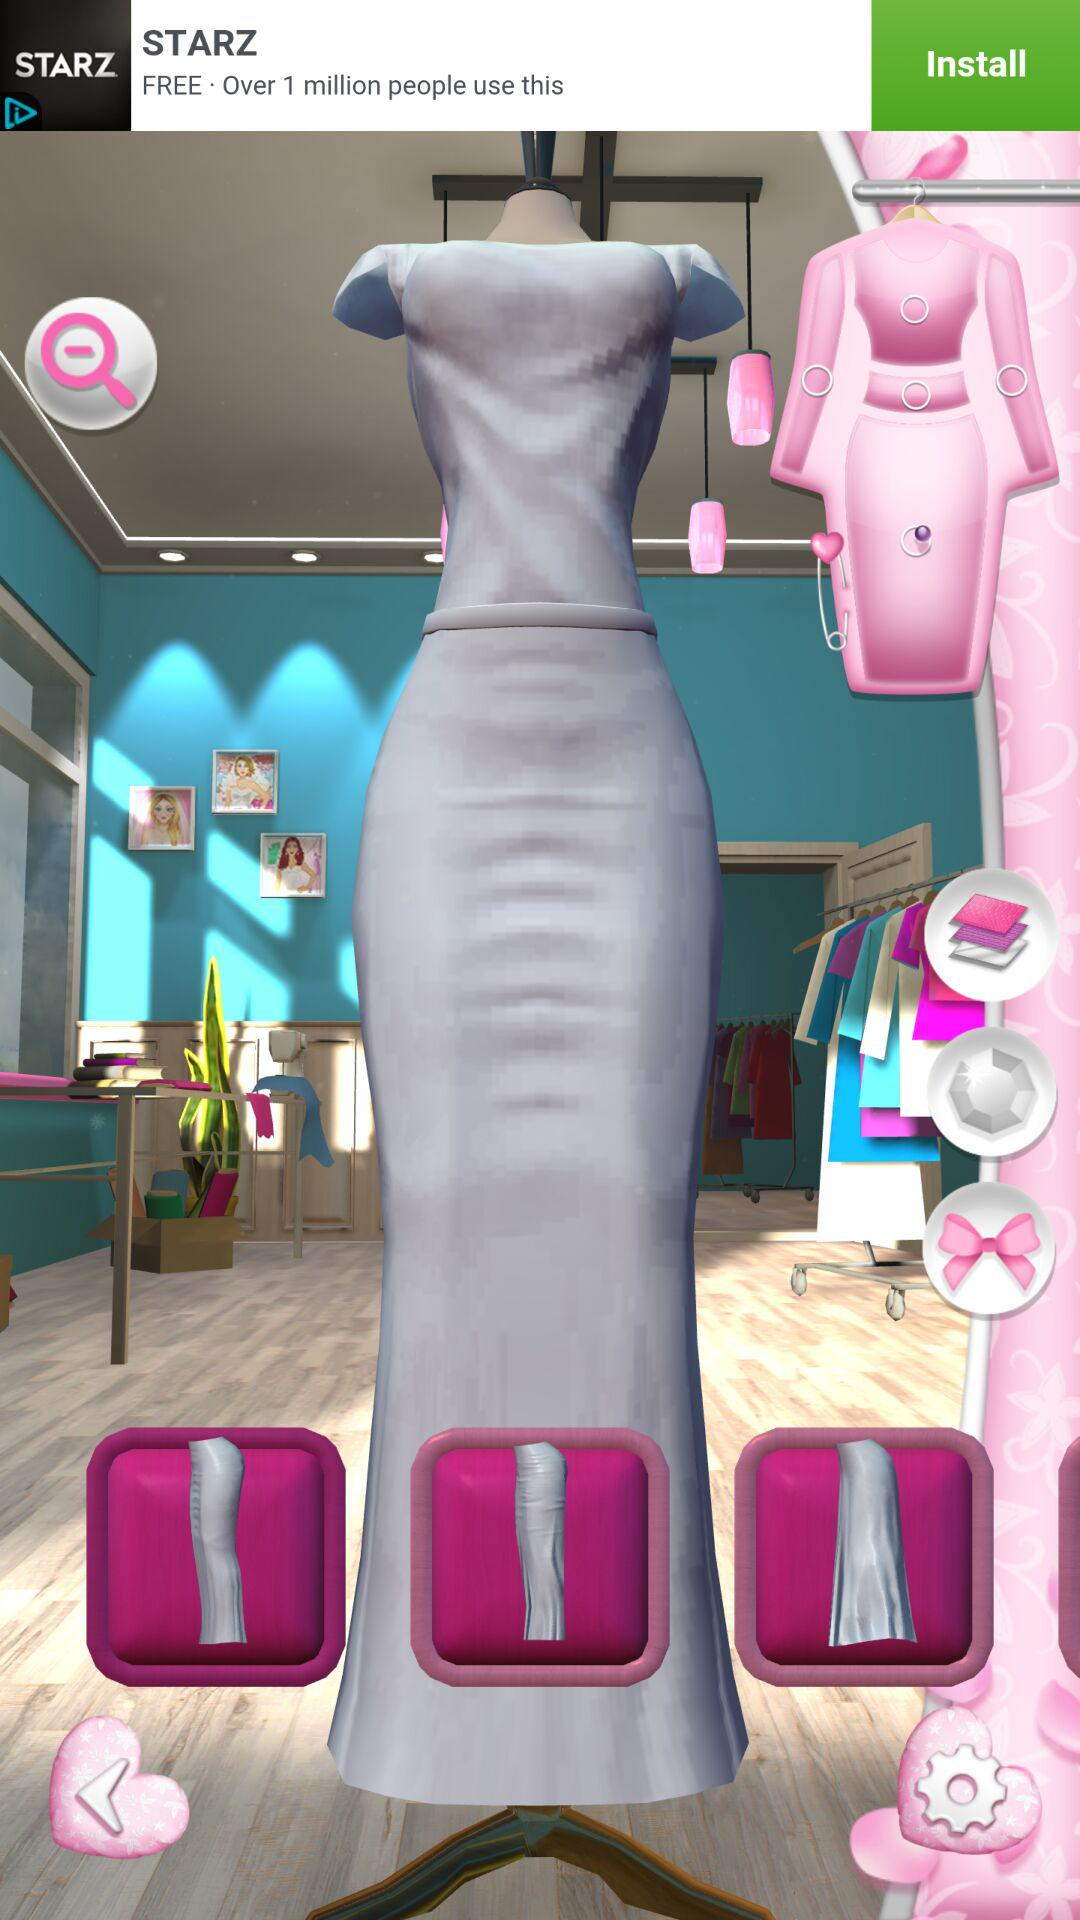How many pink squares with a white item inside of it are there?
Answer the question using a single word or phrase. 3 